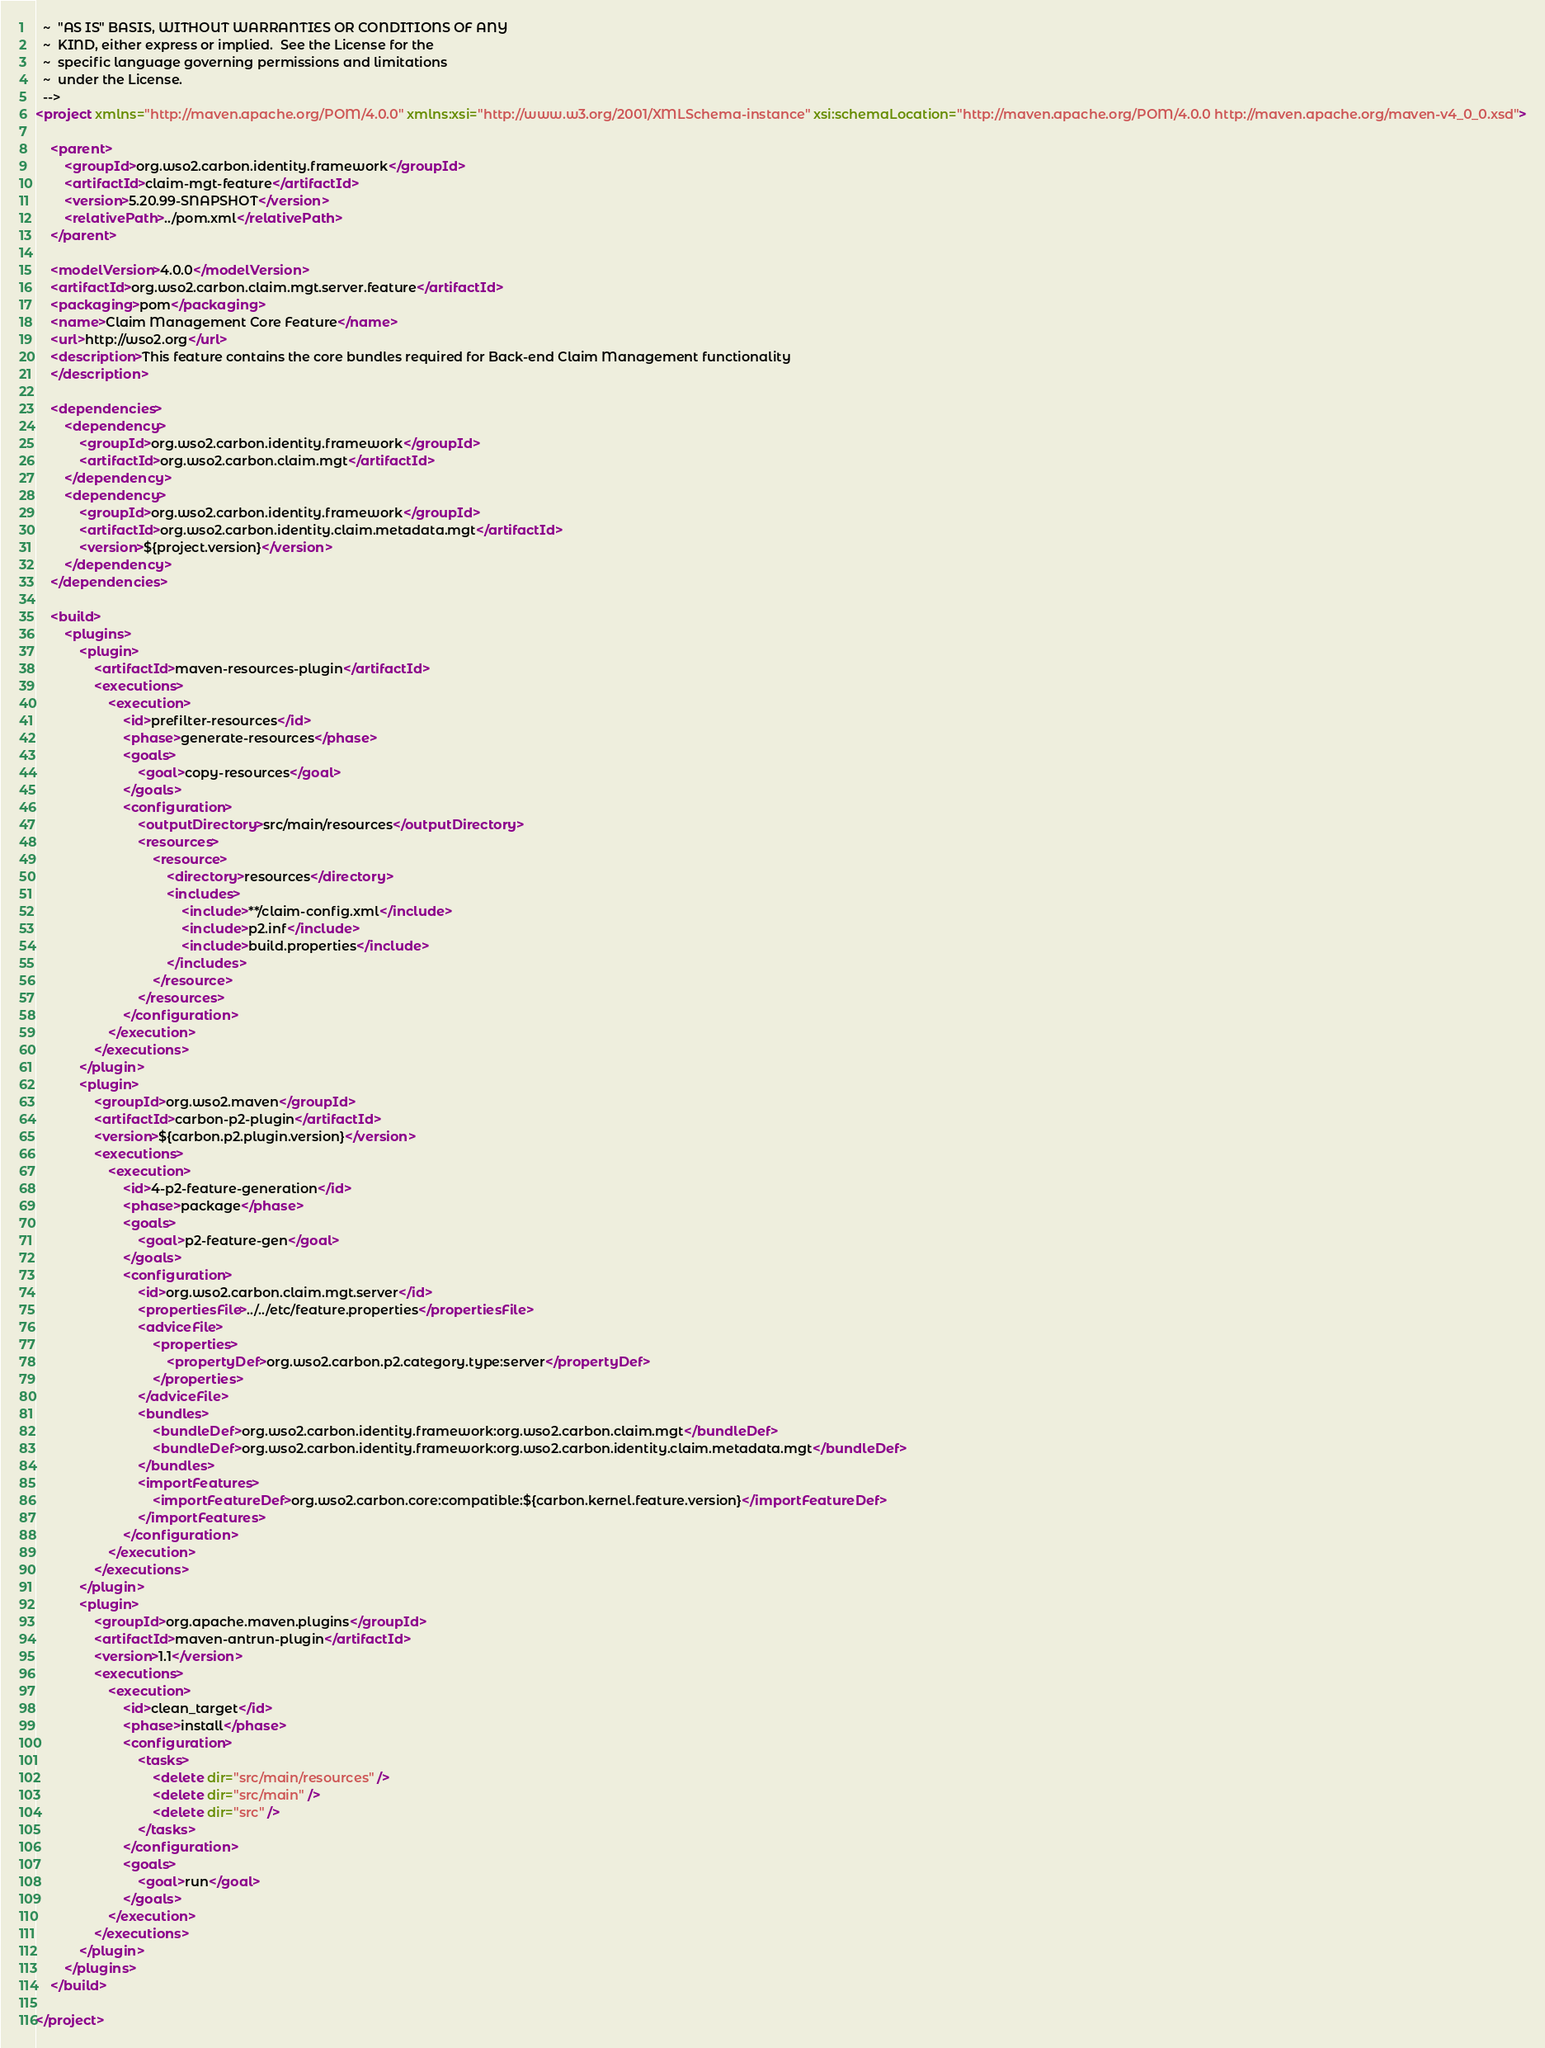<code> <loc_0><loc_0><loc_500><loc_500><_XML_>  ~  "AS IS" BASIS, WITHOUT WARRANTIES OR CONDITIONS OF ANY
  ~  KIND, either express or implied.  See the License for the
  ~  specific language governing permissions and limitations
  ~  under the License.
  -->
<project xmlns="http://maven.apache.org/POM/4.0.0" xmlns:xsi="http://www.w3.org/2001/XMLSchema-instance" xsi:schemaLocation="http://maven.apache.org/POM/4.0.0 http://maven.apache.org/maven-v4_0_0.xsd">

    <parent>
        <groupId>org.wso2.carbon.identity.framework</groupId>
        <artifactId>claim-mgt-feature</artifactId>
        <version>5.20.99-SNAPSHOT</version>
        <relativePath>../pom.xml</relativePath>
    </parent>

    <modelVersion>4.0.0</modelVersion>
    <artifactId>org.wso2.carbon.claim.mgt.server.feature</artifactId>
    <packaging>pom</packaging>
    <name>Claim Management Core Feature</name>
    <url>http://wso2.org</url>
    <description>This feature contains the core bundles required for Back-end Claim Management functionality
    </description>
    
    <dependencies>
        <dependency>
            <groupId>org.wso2.carbon.identity.framework</groupId>
            <artifactId>org.wso2.carbon.claim.mgt</artifactId>
        </dependency>
        <dependency>
            <groupId>org.wso2.carbon.identity.framework</groupId>
            <artifactId>org.wso2.carbon.identity.claim.metadata.mgt</artifactId>
            <version>${project.version}</version>
        </dependency>
    </dependencies>

    <build>
        <plugins>
            <plugin>
                <artifactId>maven-resources-plugin</artifactId>
                <executions>
                    <execution>
                        <id>prefilter-resources</id>
                        <phase>generate-resources</phase>
                        <goals>
                            <goal>copy-resources</goal>
                        </goals>
                        <configuration>
                            <outputDirectory>src/main/resources</outputDirectory>
                            <resources>
                                <resource>
                                    <directory>resources</directory>
                                    <includes>
                                        <include>**/claim-config.xml</include>
                                        <include>p2.inf</include>
                                        <include>build.properties</include>
                                    </includes>
                                </resource>
                            </resources>
                        </configuration>
                    </execution>
                </executions>
            </plugin>
            <plugin>
                <groupId>org.wso2.maven</groupId>
                <artifactId>carbon-p2-plugin</artifactId>
                <version>${carbon.p2.plugin.version}</version>
                <executions>
                    <execution>
                        <id>4-p2-feature-generation</id>
                        <phase>package</phase>
                        <goals>
                            <goal>p2-feature-gen</goal>
                        </goals>
                        <configuration>
                            <id>org.wso2.carbon.claim.mgt.server</id>
                            <propertiesFile>../../etc/feature.properties</propertiesFile>
                            <adviceFile>
                                <properties>
                                    <propertyDef>org.wso2.carbon.p2.category.type:server</propertyDef>
                                </properties>
                            </adviceFile>
                            <bundles>
                                <bundleDef>org.wso2.carbon.identity.framework:org.wso2.carbon.claim.mgt</bundleDef>
                                <bundleDef>org.wso2.carbon.identity.framework:org.wso2.carbon.identity.claim.metadata.mgt</bundleDef>
                            </bundles>
                            <importFeatures>
                                <importFeatureDef>org.wso2.carbon.core:compatible:${carbon.kernel.feature.version}</importFeatureDef>
                            </importFeatures>
                        </configuration>
                    </execution>
                </executions>
            </plugin>
            <plugin>
                <groupId>org.apache.maven.plugins</groupId>
                <artifactId>maven-antrun-plugin</artifactId>
                <version>1.1</version>
                <executions>
                    <execution>
                        <id>clean_target</id>
                        <phase>install</phase>
                        <configuration>
                            <tasks>
                                <delete dir="src/main/resources" />
                                <delete dir="src/main" />
                                <delete dir="src" />
                            </tasks>
                        </configuration>
                        <goals>
                            <goal>run</goal>
                        </goals>
                    </execution>
                </executions>
            </plugin>
        </plugins>
    </build>

</project>
</code> 